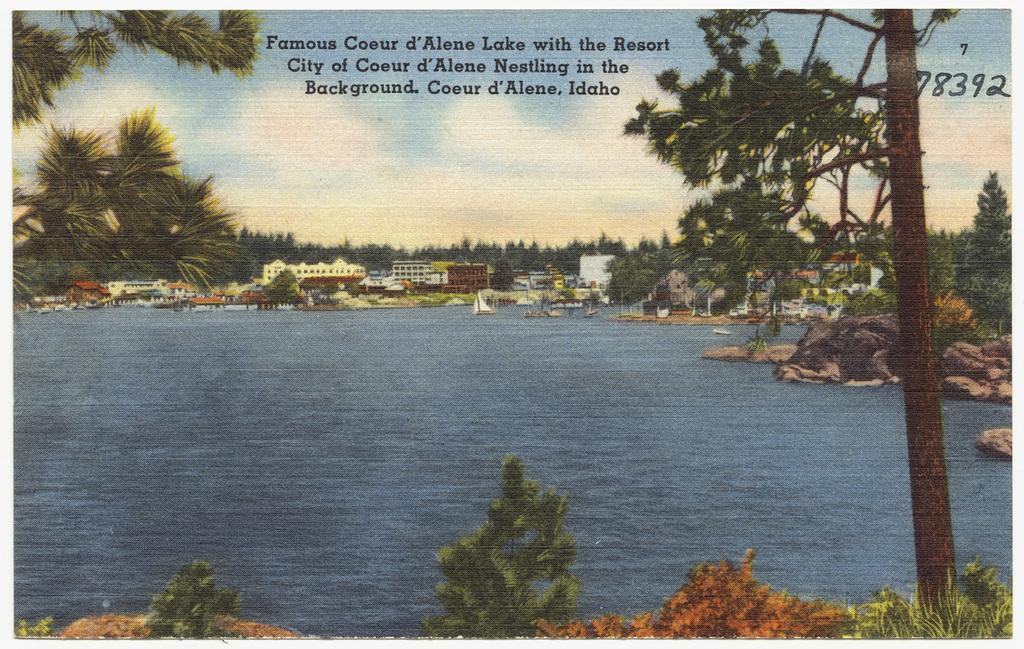Could you give a brief overview of what you see in this image? In this image we can see a poster with some boats on the water, there are some buildings, trees, plants and rocks, at the top of the image we can see the text and in the back ground we can see the sky with clouds. 